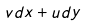Convert formula to latex. <formula><loc_0><loc_0><loc_500><loc_500>v d x + u d y</formula> 